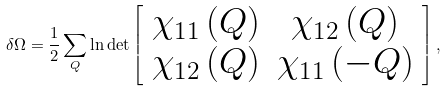Convert formula to latex. <formula><loc_0><loc_0><loc_500><loc_500>\delta \Omega = \frac { 1 } { 2 } \sum _ { Q } \ln \det \left [ \begin{array} { c c } \chi _ { 1 1 } \left ( Q \right ) & \chi _ { 1 2 } \left ( Q \right ) \\ \chi _ { 1 2 } \left ( Q \right ) & \chi _ { 1 1 } \left ( { - } Q \right ) \end{array} \right ] ,</formula> 